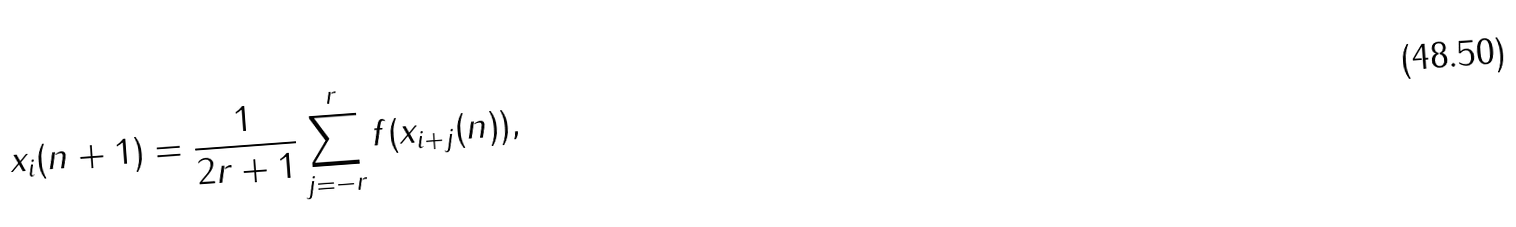Convert formula to latex. <formula><loc_0><loc_0><loc_500><loc_500>x _ { i } ( n + 1 ) = \frac { 1 } { 2 r + 1 } \sum _ { j = - r } ^ { r } f ( x _ { i + j } ( n ) ) ,</formula> 